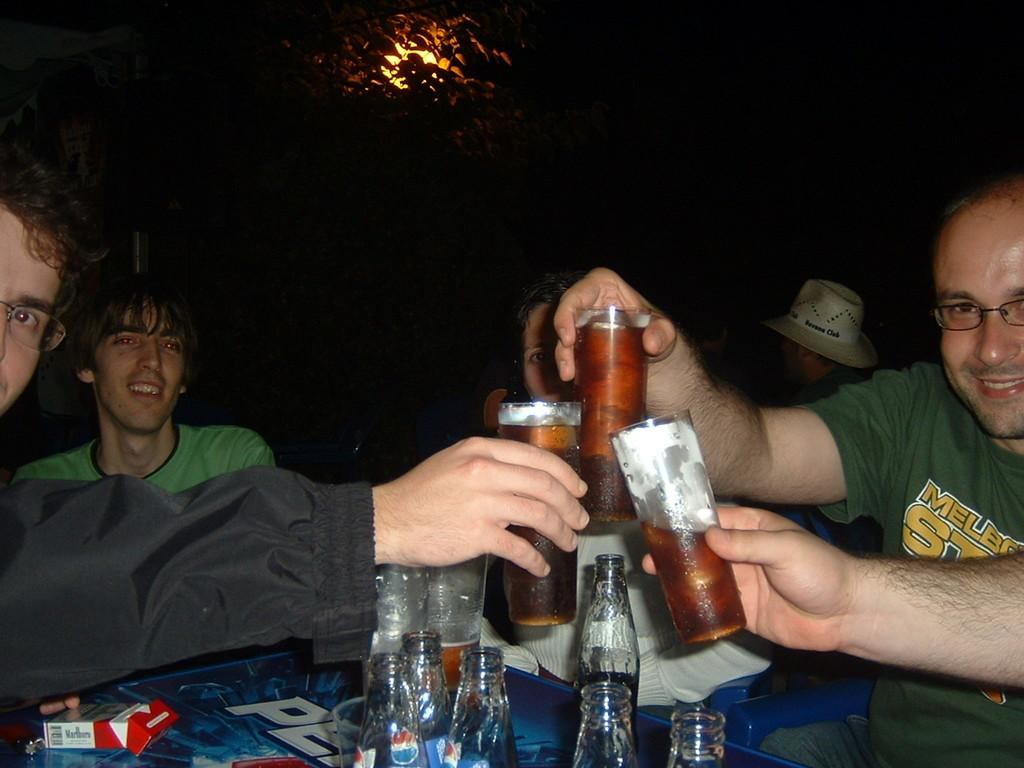<image>
Provide a brief description of the given image. Three men toasting drinks on a pepsi table with a pack of Marlboro reds on it. 